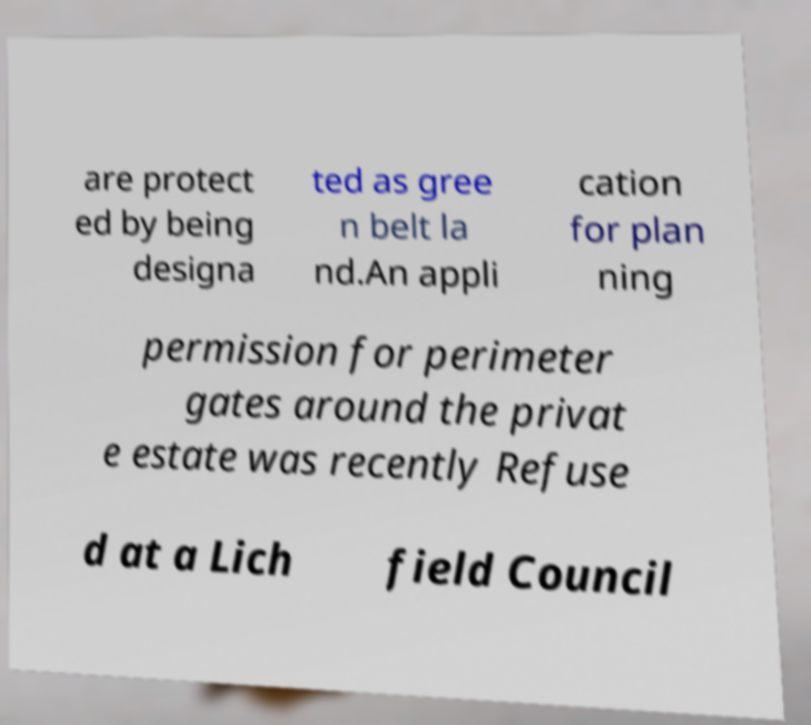Could you extract and type out the text from this image? are protect ed by being designa ted as gree n belt la nd.An appli cation for plan ning permission for perimeter gates around the privat e estate was recently Refuse d at a Lich field Council 